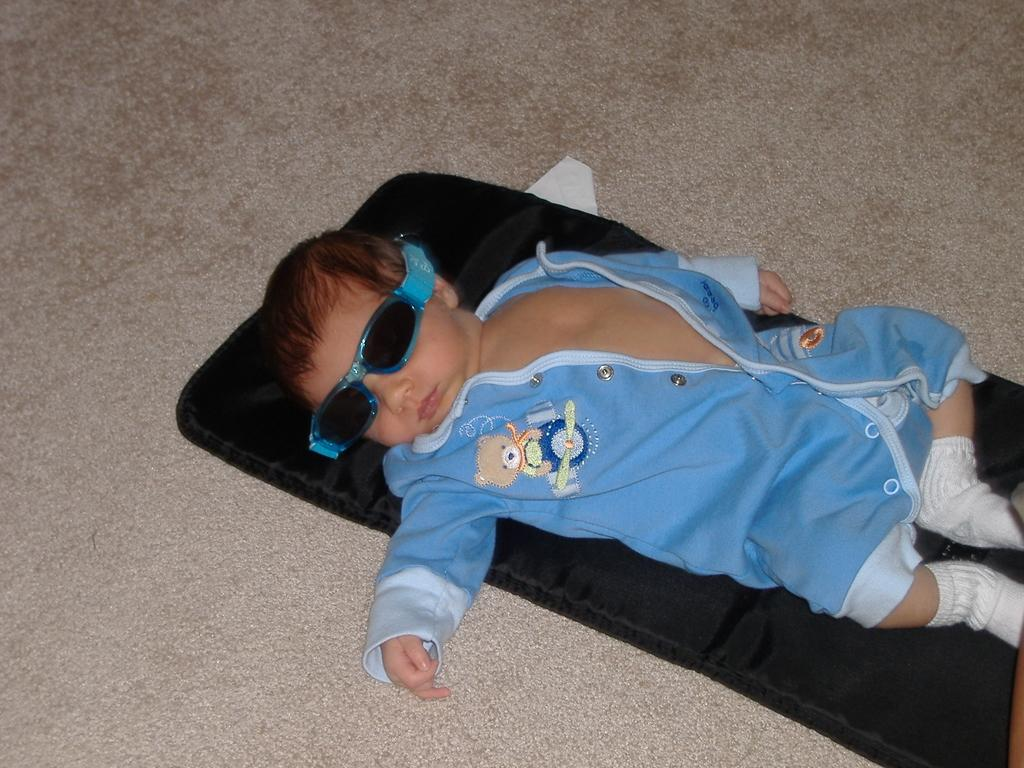Where was the image taken? The image was clicked indoors. Who is in the image? There is a kid in the image. What is the kid wearing? The kid is wearing a blue dress and goggles. What is the kid doing in the image? The kid is lying on a black object. Where is the black object placed? The black object is placed on the ground. Can you see any grapes in the kid's mouth in the image? There are no grapes or any indication of a mouth in the image, as the kid is wearing goggles and the focus is on their position on the black object. 